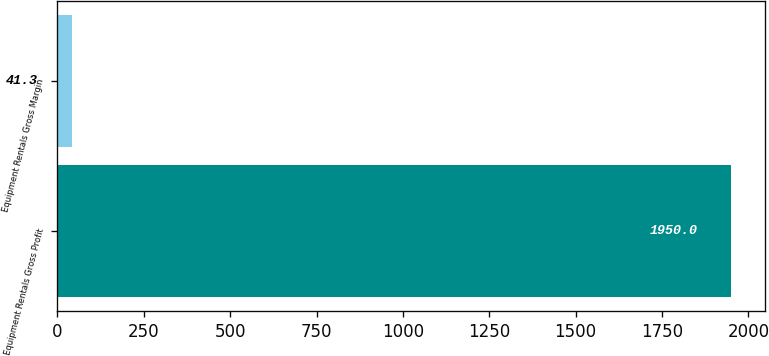Convert chart to OTSL. <chart><loc_0><loc_0><loc_500><loc_500><bar_chart><fcel>Equipment Rentals Gross Profit<fcel>Equipment Rentals Gross Margin<nl><fcel>1950<fcel>41.3<nl></chart> 